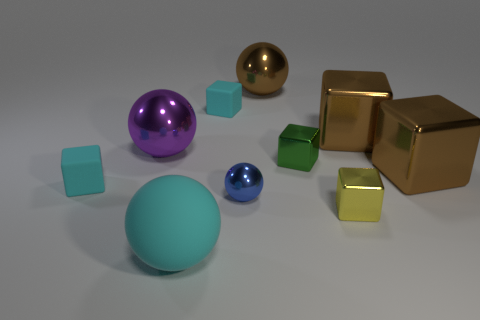Subtract all cyan cubes. How many cubes are left? 4 Subtract all cyan matte blocks. How many blocks are left? 4 Subtract 3 blocks. How many blocks are left? 3 Subtract all yellow blocks. Subtract all brown balls. How many blocks are left? 5 Subtract all cubes. How many objects are left? 4 Add 9 small matte balls. How many small matte balls exist? 9 Subtract 1 blue spheres. How many objects are left? 9 Subtract all large blue blocks. Subtract all big brown balls. How many objects are left? 9 Add 7 matte spheres. How many matte spheres are left? 8 